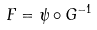Convert formula to latex. <formula><loc_0><loc_0><loc_500><loc_500>F = \psi \circ G ^ { - 1 }</formula> 